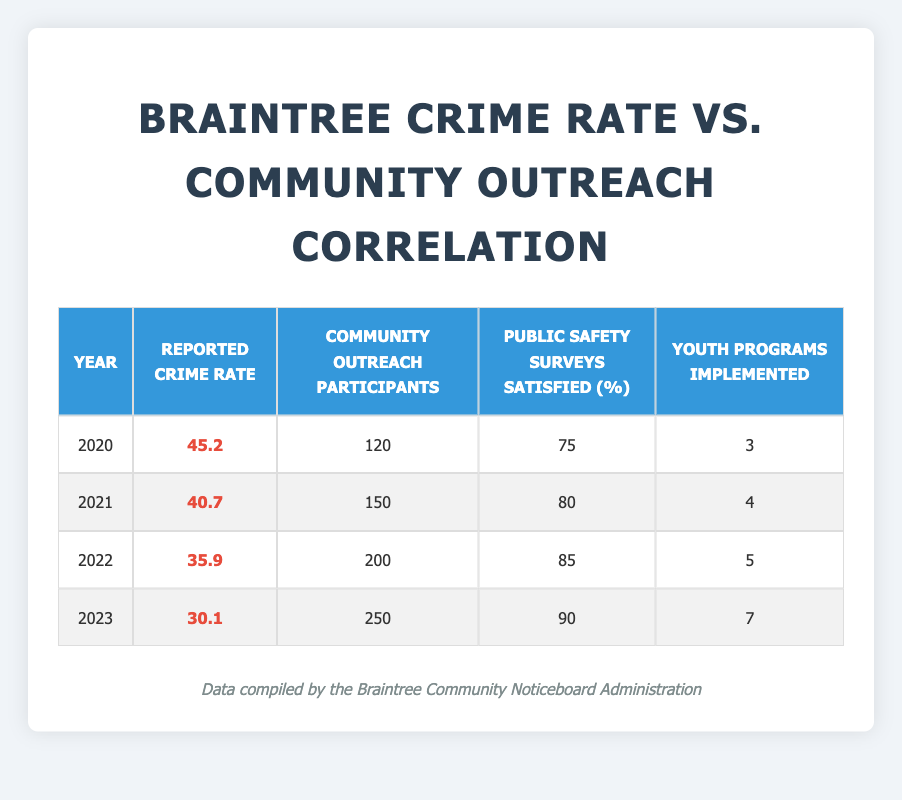What was the reported crime rate in 2022? The table shows that the reported crime rate for the year 2022 is 35.9.
Answer: 35.9 How many community outreach participants were there in 2021? According to the table, there were 150 community outreach participants in the year 2021.
Answer: 150 What is the average reported crime rate from 2020 to 2023? To find the average, I add all reported crime rates: (45.2 + 40.7 + 35.9 + 30.1) = 151.9. Then, I divide by the number of years (4), which gives 151.9 / 4 = 37.975.
Answer: 37.975 Did the number of youth programs implemented increase each year? By examining the table, I see that the number of youth programs implemented increased from 3 in 2020 to 7 in 2023. Therefore, the statement is true.
Answer: Yes What was the difference in community outreach participants between 2020 and 2023? In 2020, there were 120 community outreach participants, and in 2023, there were 250. The difference is calculated as 250 - 120 = 130.
Answer: 130 Was the public safety survey satisfaction rate higher in 2022 than in 2021? In the table, the public safety survey satisfaction in 2022 is 85%, while in 2021 it is 80%. This shows that 2022 had a higher satisfaction rate.
Answer: Yes What is the total number of community outreach participants from 2020 to 2023? I can find this total by adding the participants for each year: (120 + 150 + 200 + 250) = 720.
Answer: 720 What percentage increase in public safety surveys satisfied occurred from 2020 to 2023? The satisfaction rate increased from 75% in 2020 to 90% in 2023. The increase is 90 - 75 = 15. To find the percentage increase: (15 / 75) * 100 = 20%.
Answer: 20% 